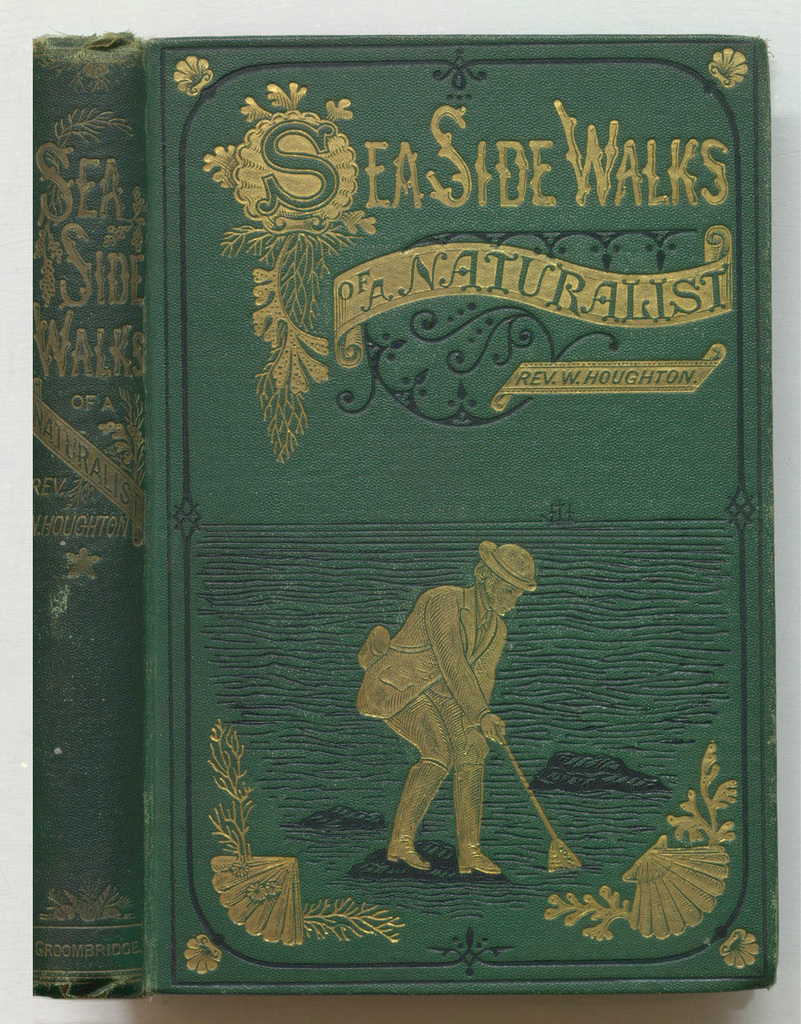Can you describe what the figures on the book cover represent in terms of the book's theme? The figure of the naturalist with a net and bag, meticulously examining the seaside, encapsulates the book's exploration of marine and coastal biology, reflecting the author's detailed observations of natural environments. 